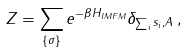<formula> <loc_0><loc_0><loc_500><loc_500>Z = \sum _ { \{ \sigma \} } e ^ { - \beta H _ { I M F M } } \delta _ { \sum _ { i } s _ { i } , A } \, ,</formula> 